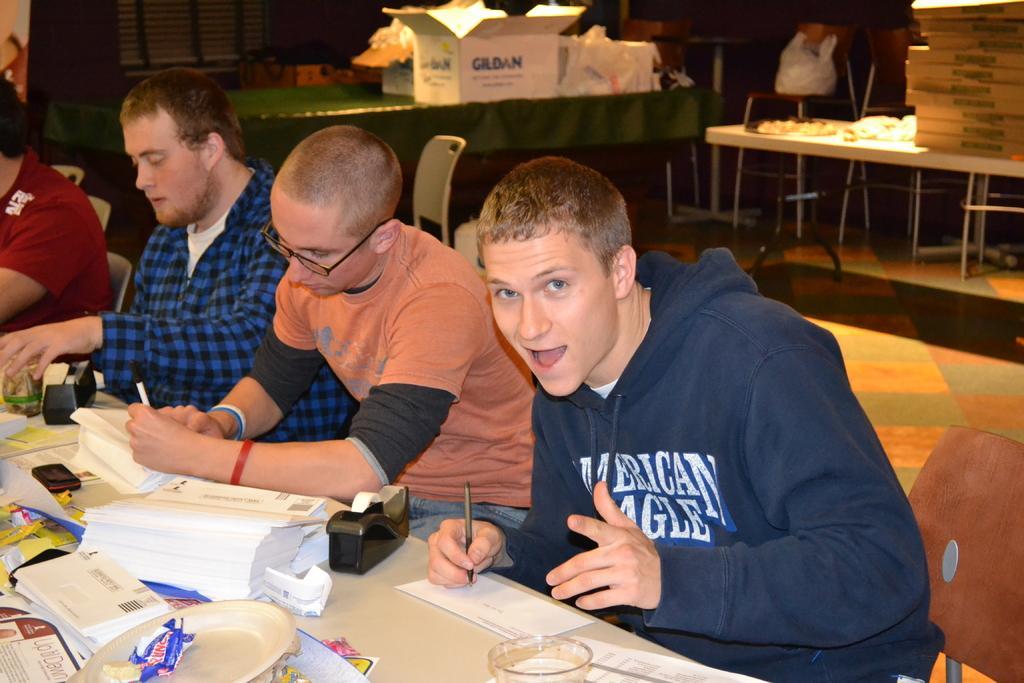In one or two sentences, can you explain what this image depicts? This is an image clicked inside the room. In this I can see four men are sitting on the chairs in front of the table. On the table I can see few books, bowls and mobile. These persons are writing something on the paper with a pen. In the background there are few tables. On the tables I can see some boxes. 